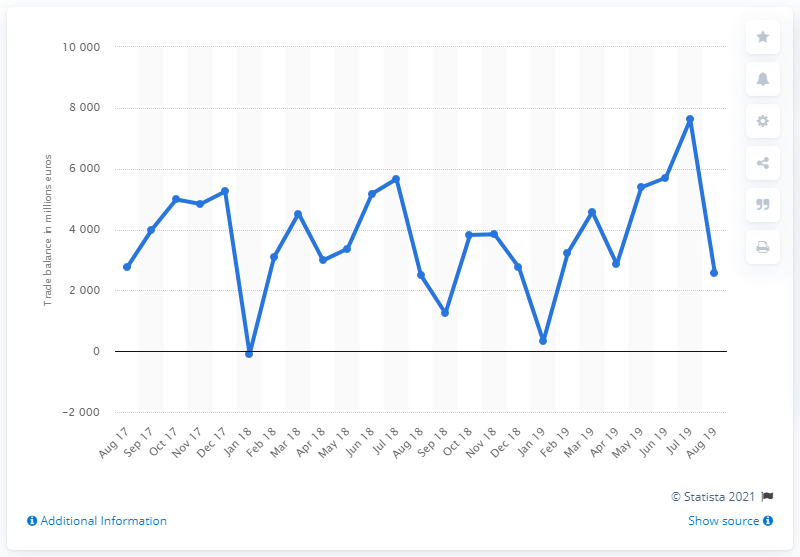Specify some key components in this picture. In August 2019, Italy experienced a trade surplus of 2,585. In August 2019, Italy's trade balance decreased by 3990.59 compared to the previous month. 